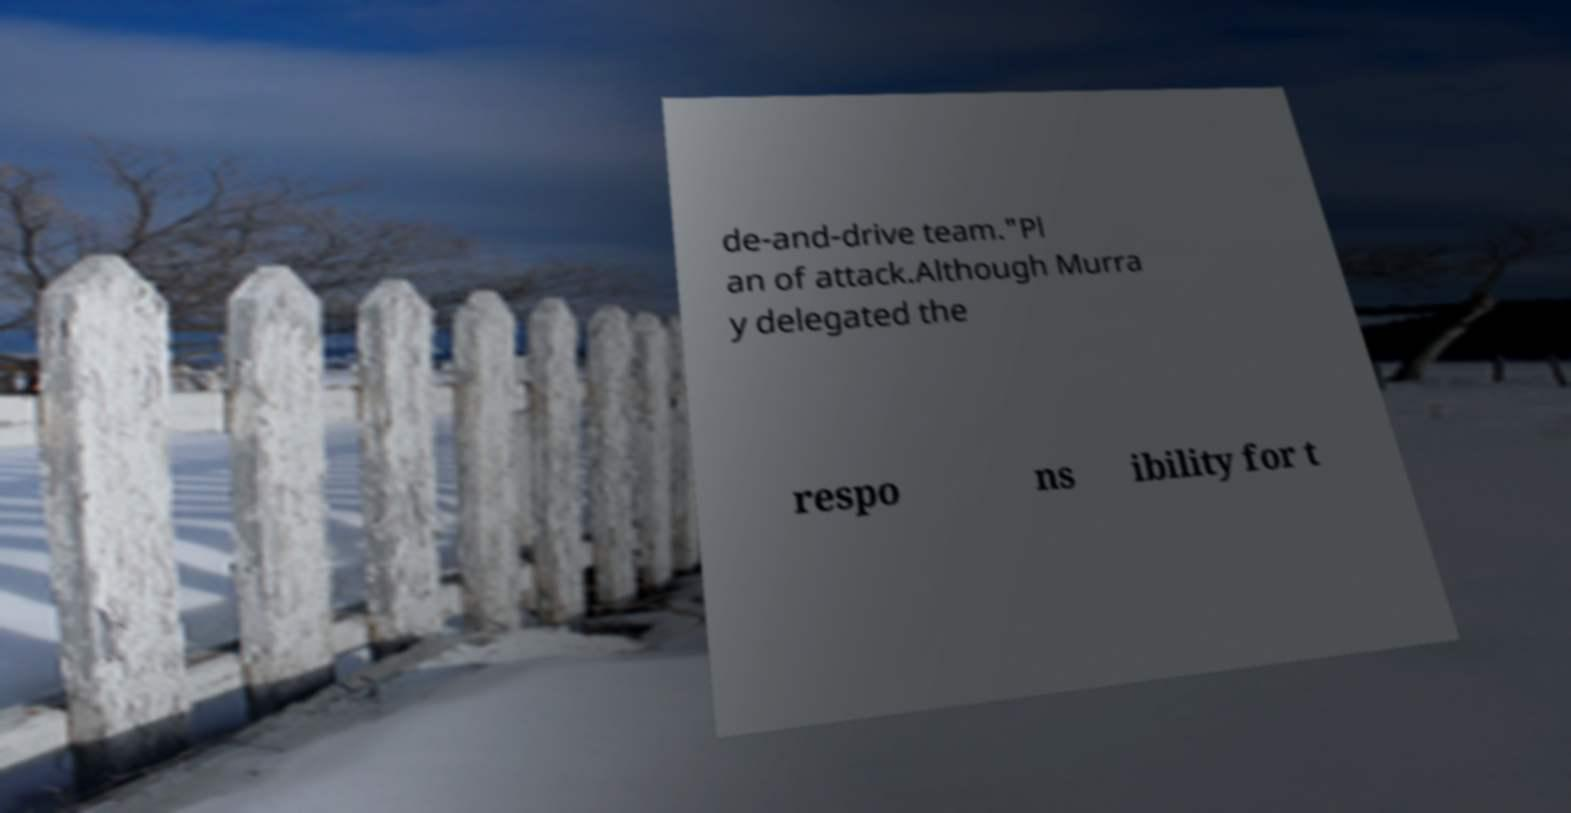For documentation purposes, I need the text within this image transcribed. Could you provide that? de-and-drive team."Pl an of attack.Although Murra y delegated the respo ns ibility for t 